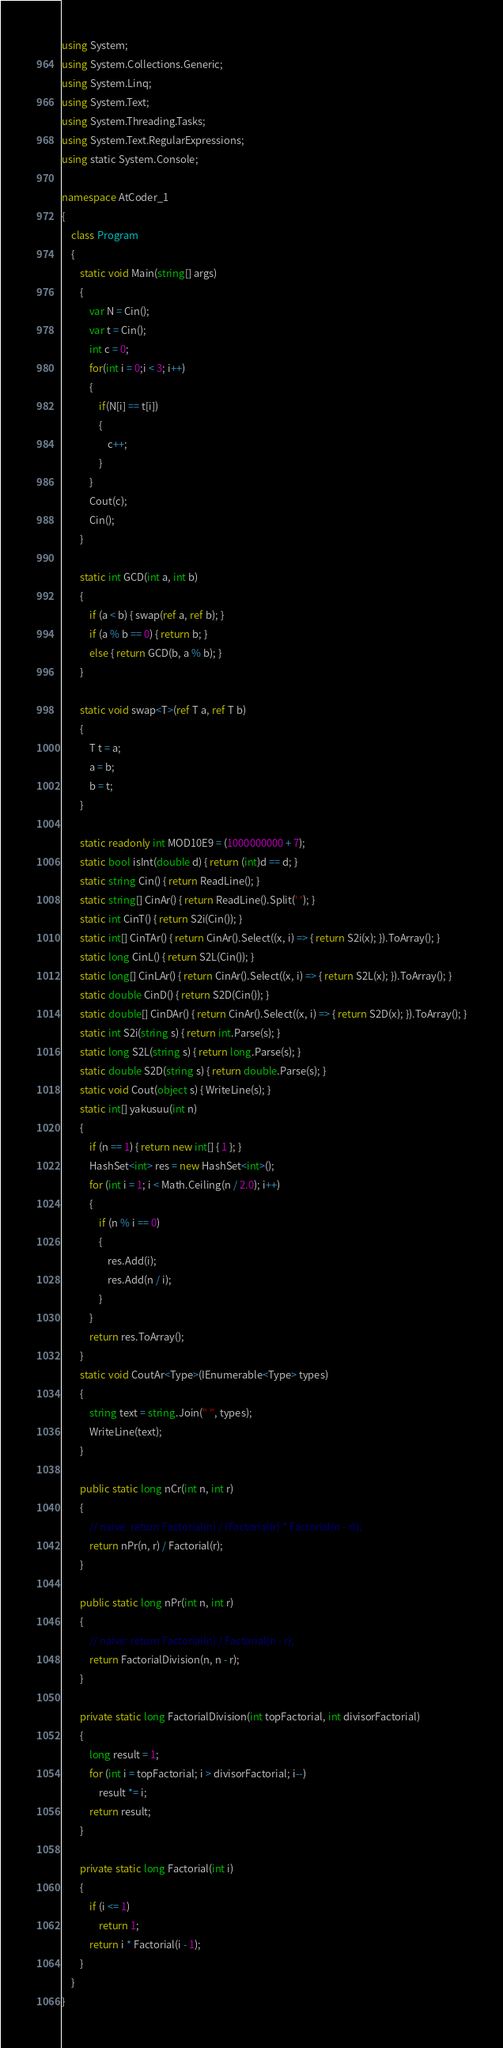<code> <loc_0><loc_0><loc_500><loc_500><_C#_>using System;
using System.Collections.Generic;
using System.Linq;
using System.Text;
using System.Threading.Tasks;
using System.Text.RegularExpressions;
using static System.Console;

namespace AtCoder_1
{
    class Program
    {
        static void Main(string[] args)
        {
            var N = Cin();
            var t = Cin();
            int c = 0;
            for(int i = 0;i < 3; i++)
            {
                if(N[i] == t[i])
                {
                    c++;
                }
            }
            Cout(c);
            Cin();
        }

        static int GCD(int a, int b)
        {
            if (a < b) { swap(ref a, ref b); }
            if (a % b == 0) { return b; }
            else { return GCD(b, a % b); }
        }

        static void swap<T>(ref T a, ref T b)
        {
            T t = a;
            a = b;
            b = t;
        }

        static readonly int MOD10E9 = (1000000000 + 7);
        static bool isInt(double d) { return (int)d == d; }
        static string Cin() { return ReadLine(); }
        static string[] CinAr() { return ReadLine().Split(' '); }
        static int CinT() { return S2i(Cin()); }
        static int[] CinTAr() { return CinAr().Select((x, i) => { return S2i(x); }).ToArray(); }
        static long CinL() { return S2L(Cin()); }
        static long[] CinLAr() { return CinAr().Select((x, i) => { return S2L(x); }).ToArray(); }
        static double CinD() { return S2D(Cin()); }
        static double[] CinDAr() { return CinAr().Select((x, i) => { return S2D(x); }).ToArray(); }
        static int S2i(string s) { return int.Parse(s); }
        static long S2L(string s) { return long.Parse(s); }
        static double S2D(string s) { return double.Parse(s); }
        static void Cout(object s) { WriteLine(s); }
        static int[] yakusuu(int n)
        {
            if (n == 1) { return new int[] { 1 }; }
            HashSet<int> res = new HashSet<int>();
            for (int i = 1; i < Math.Ceiling(n / 2.0); i++)
            {
                if (n % i == 0)
                {
                    res.Add(i);
                    res.Add(n / i);
                }
            }
            return res.ToArray();
        }
        static void CoutAr<Type>(IEnumerable<Type> types)
        {
            string text = string.Join(" ", types);
            WriteLine(text);
        }

        public static long nCr(int n, int r)
        {
            // naive: return Factorial(n) / (Factorial(r) * Factorial(n - r));
            return nPr(n, r) / Factorial(r);
        }

        public static long nPr(int n, int r)
        {
            // naive: return Factorial(n) / Factorial(n - r);
            return FactorialDivision(n, n - r);
        }

        private static long FactorialDivision(int topFactorial, int divisorFactorial)
        {
            long result = 1;
            for (int i = topFactorial; i > divisorFactorial; i--)
                result *= i;
            return result;
        }

        private static long Factorial(int i)
        {
            if (i <= 1)
                return 1;
            return i * Factorial(i - 1);
        }
    }
}
</code> 